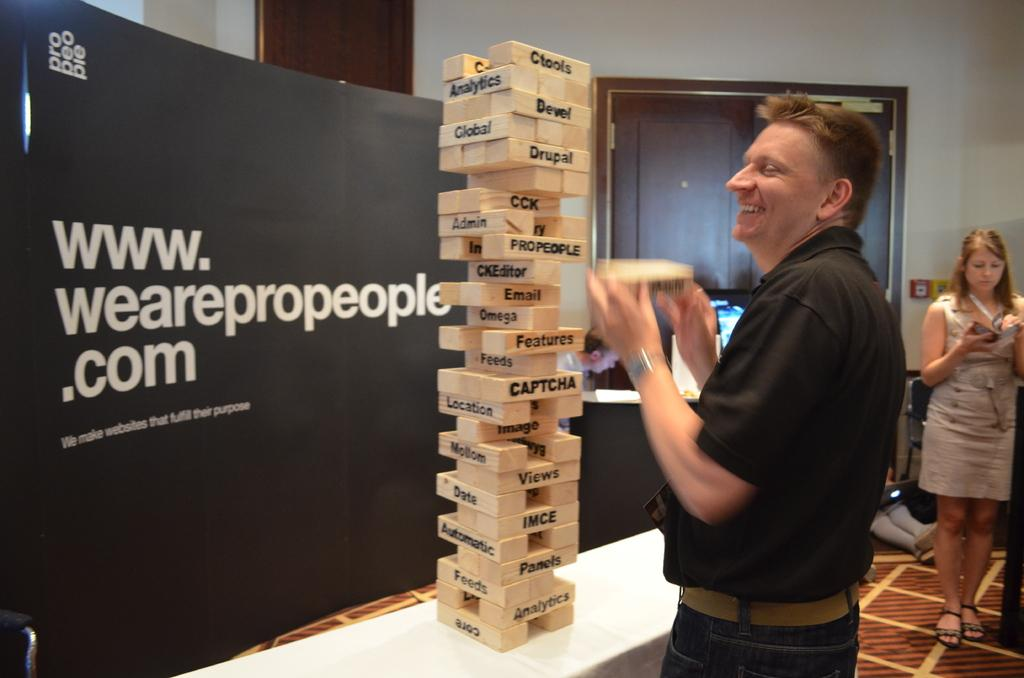Provide a one-sentence caption for the provided image. A man stands next to a table playing a tall Jenga game on which each block has a word such as Features and Captcha for example. 